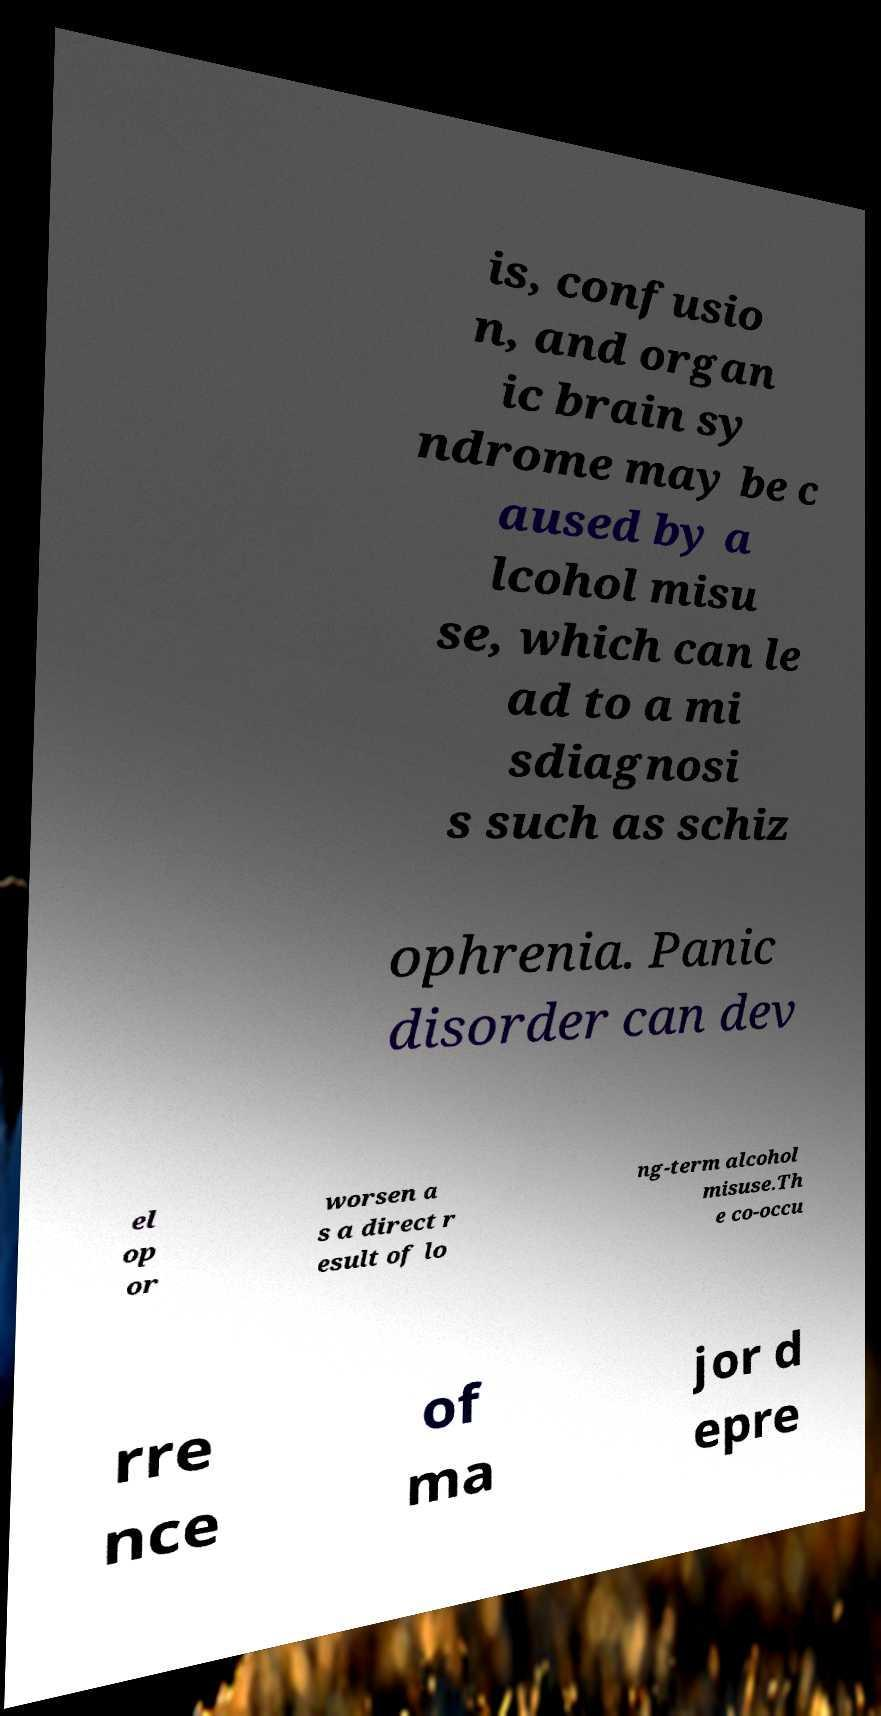There's text embedded in this image that I need extracted. Can you transcribe it verbatim? is, confusio n, and organ ic brain sy ndrome may be c aused by a lcohol misu se, which can le ad to a mi sdiagnosi s such as schiz ophrenia. Panic disorder can dev el op or worsen a s a direct r esult of lo ng-term alcohol misuse.Th e co-occu rre nce of ma jor d epre 